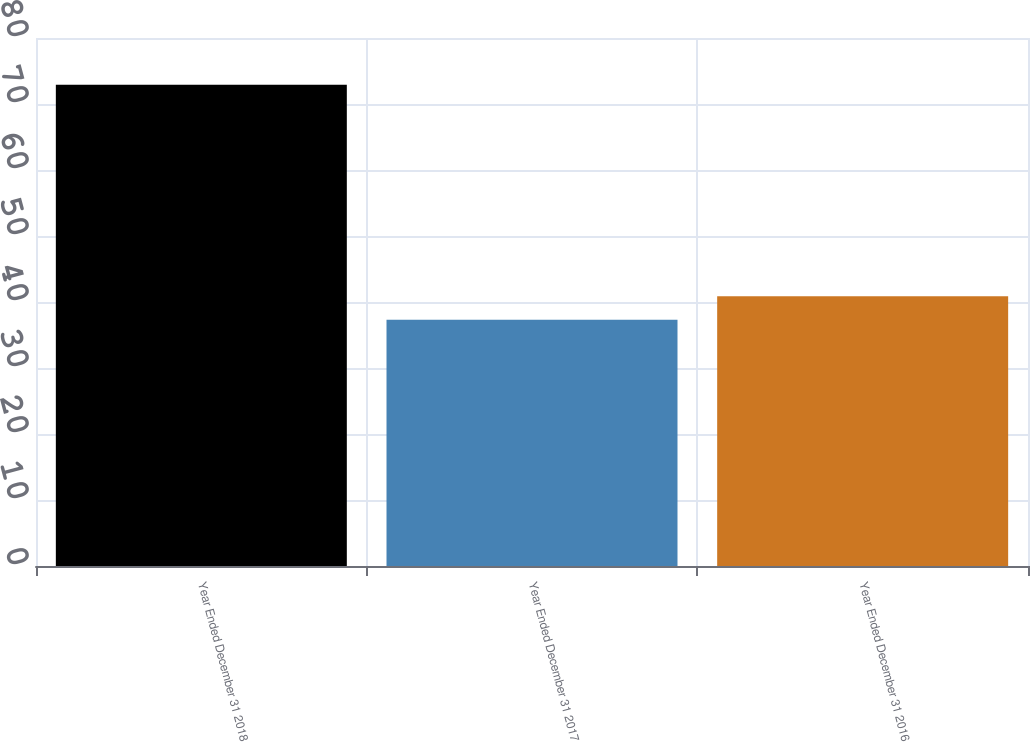Convert chart to OTSL. <chart><loc_0><loc_0><loc_500><loc_500><bar_chart><fcel>Year Ended December 31 2018<fcel>Year Ended December 31 2017<fcel>Year Ended December 31 2016<nl><fcel>72.9<fcel>37.3<fcel>40.86<nl></chart> 